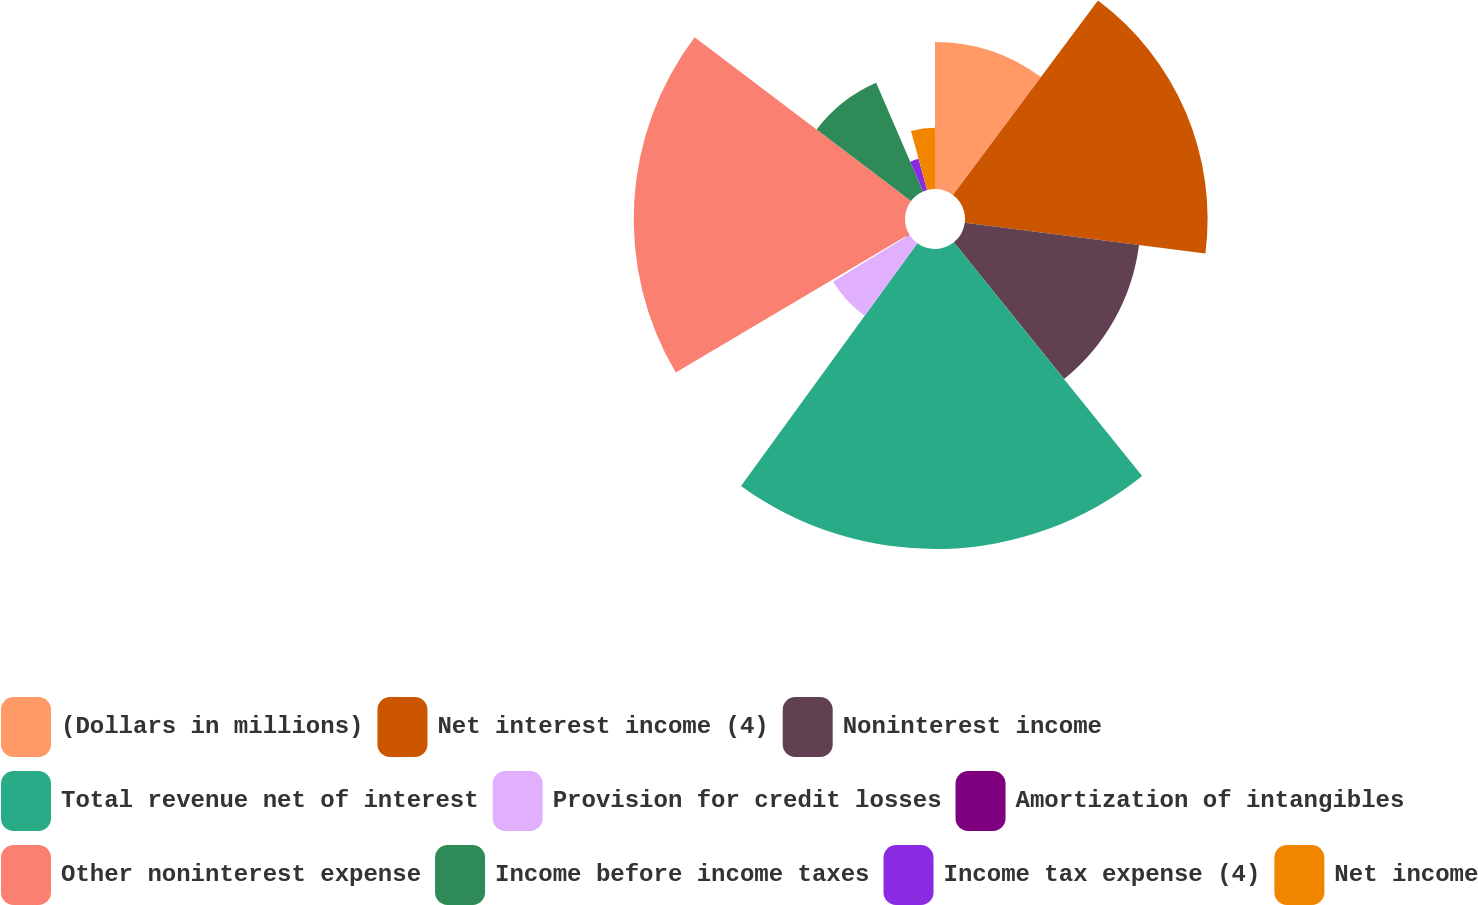Convert chart. <chart><loc_0><loc_0><loc_500><loc_500><pie_chart><fcel>(Dollars in millions)<fcel>Net interest income (4)<fcel>Noninterest income<fcel>Total revenue net of interest<fcel>Provision for credit losses<fcel>Amortization of intangibles<fcel>Other noninterest expense<fcel>Income before income taxes<fcel>Income tax expense (4)<fcel>Net income<nl><fcel>10.2%<fcel>16.82%<fcel>12.18%<fcel>20.8%<fcel>6.22%<fcel>0.27%<fcel>18.81%<fcel>8.21%<fcel>2.25%<fcel>4.24%<nl></chart> 